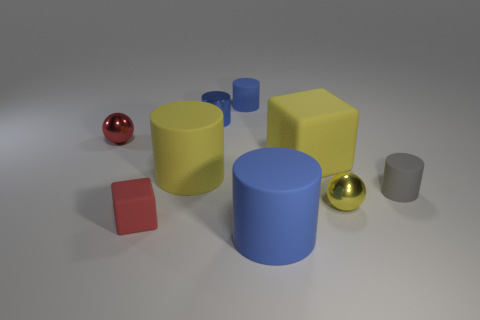Are there any other things that have the same size as the gray cylinder?
Offer a terse response. Yes. There is another object that is the same shape as the tiny yellow metal thing; what is its size?
Offer a very short reply. Small. What number of red objects are made of the same material as the large cube?
Keep it short and to the point. 1. There is a rubber block that is on the left side of the large blue cylinder; what number of tiny gray cylinders are on the left side of it?
Your response must be concise. 0. Are there any blue cylinders behind the red rubber block?
Your answer should be very brief. Yes. Does the red thing that is in front of the tiny red sphere have the same shape as the large blue rubber object?
Ensure brevity in your answer.  No. There is a tiny ball that is the same color as the small block; what material is it?
Keep it short and to the point. Metal. How many big cylinders have the same color as the small metal cylinder?
Offer a very short reply. 1. What is the shape of the blue object in front of the blue metal thing that is to the right of the large yellow cylinder?
Offer a very short reply. Cylinder. Is there a gray rubber object of the same shape as the small red rubber thing?
Provide a short and direct response. No. 